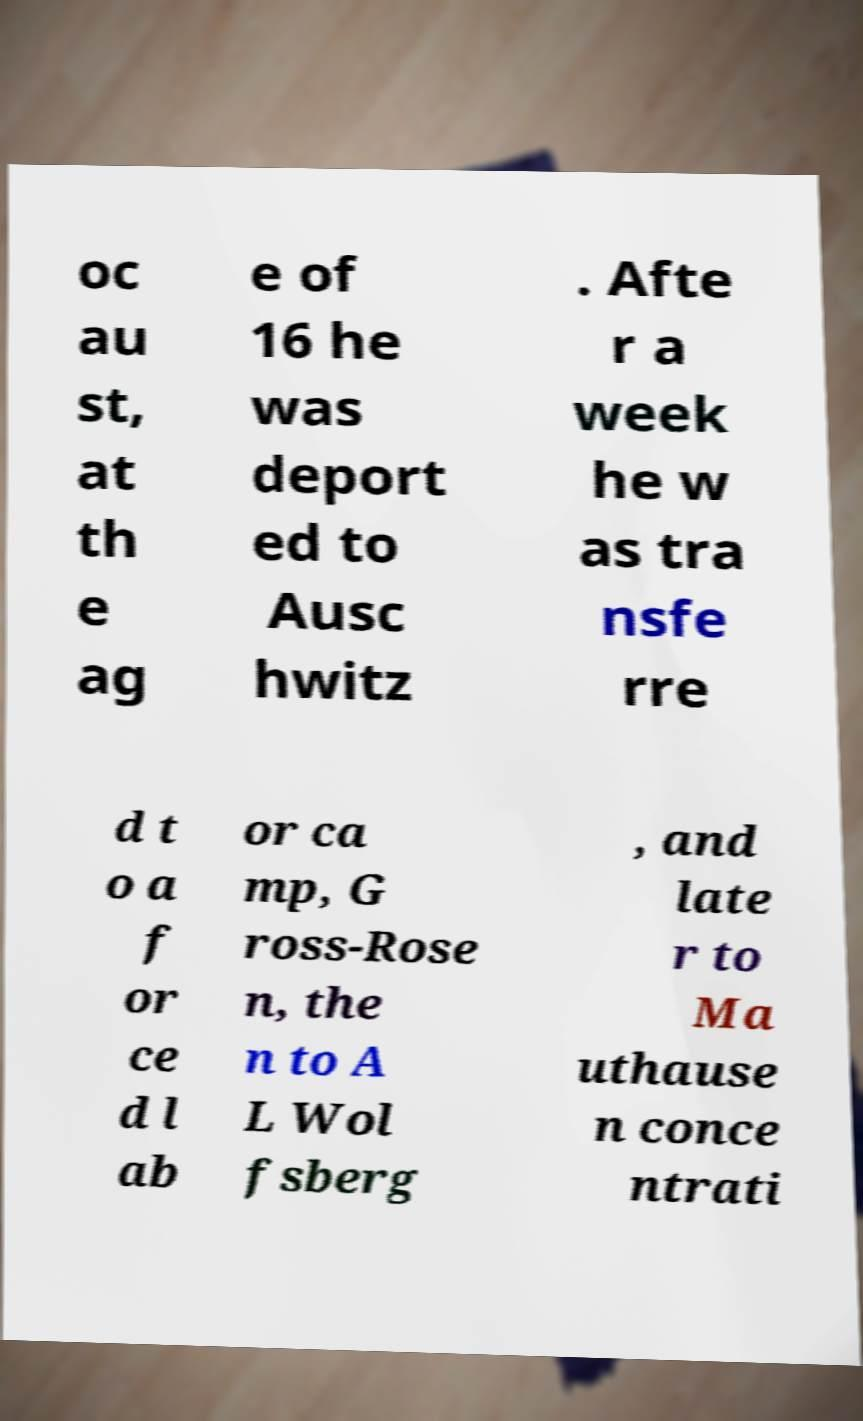Can you read and provide the text displayed in the image?This photo seems to have some interesting text. Can you extract and type it out for me? oc au st, at th e ag e of 16 he was deport ed to Ausc hwitz . Afte r a week he w as tra nsfe rre d t o a f or ce d l ab or ca mp, G ross-Rose n, the n to A L Wol fsberg , and late r to Ma uthause n conce ntrati 